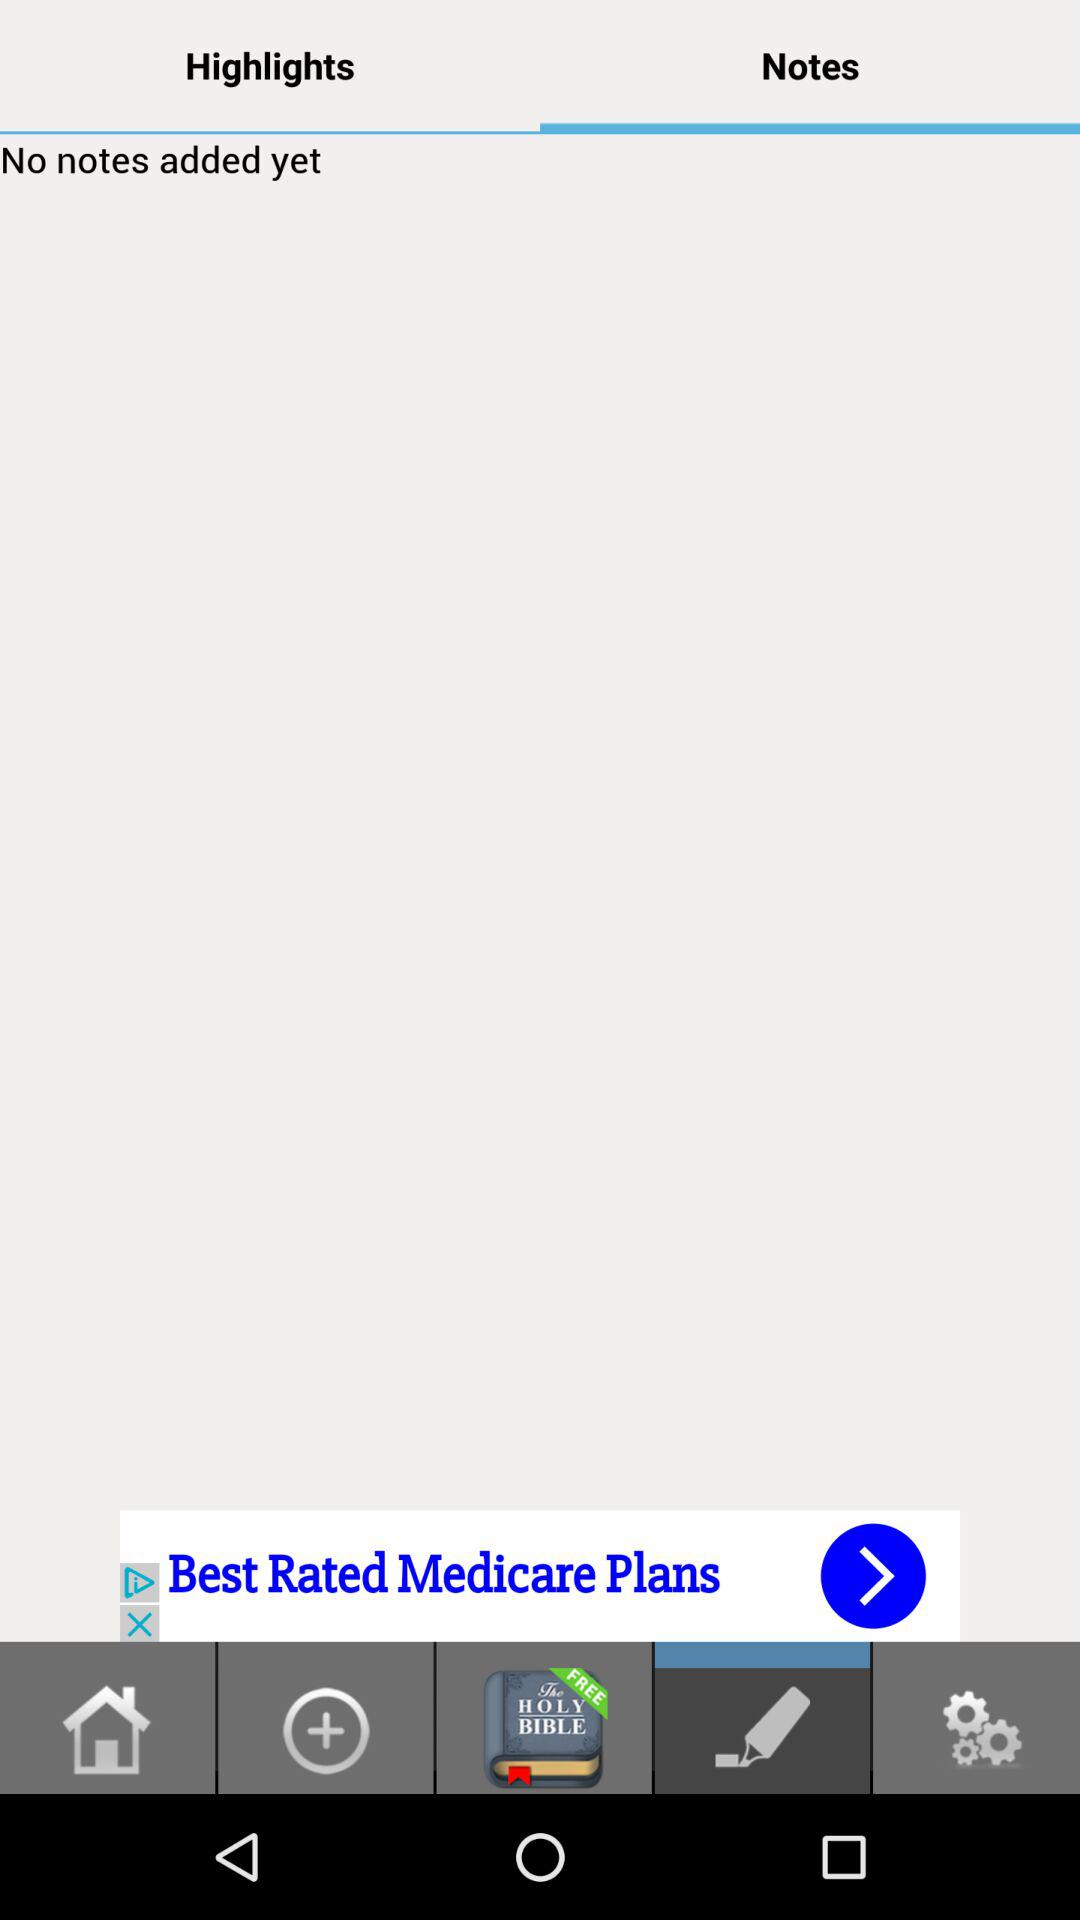Which tab am I on? You are on the "Notes" tab. 